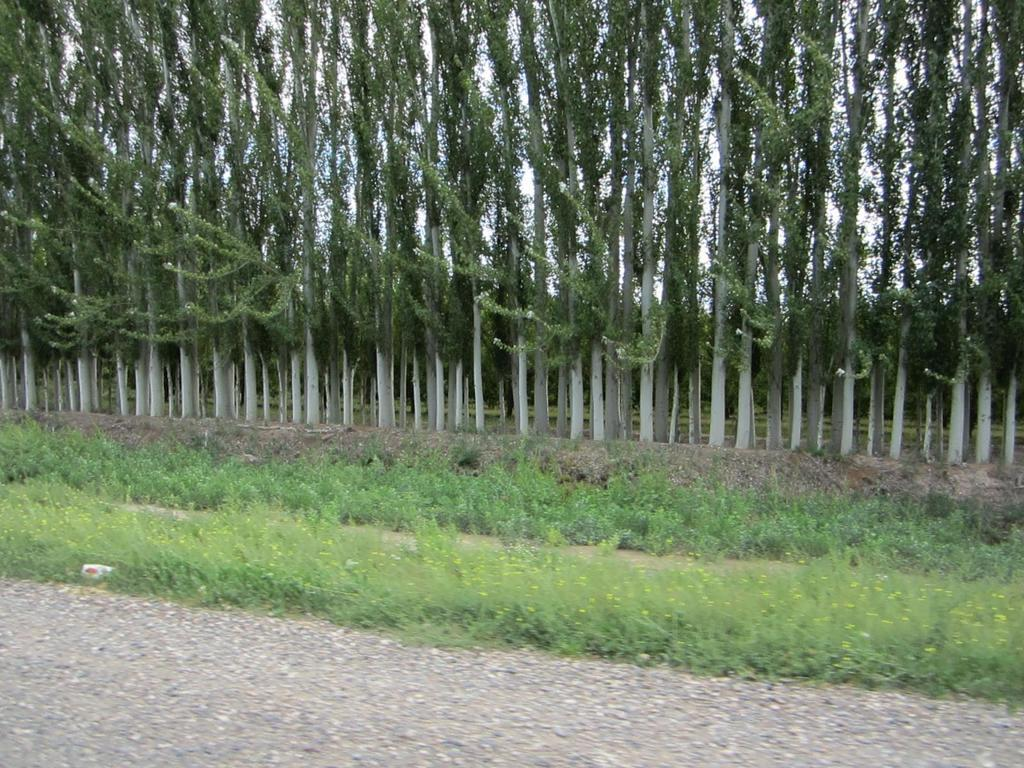What is located at the bottom of the image? There is a road at the bottom of the image. What type of vegetation can be seen in the image? There is grass in the image. What is visible in the background of the image? There are trees in the background of the image. What type of pump is visible in the image? There is no pump present in the image. 